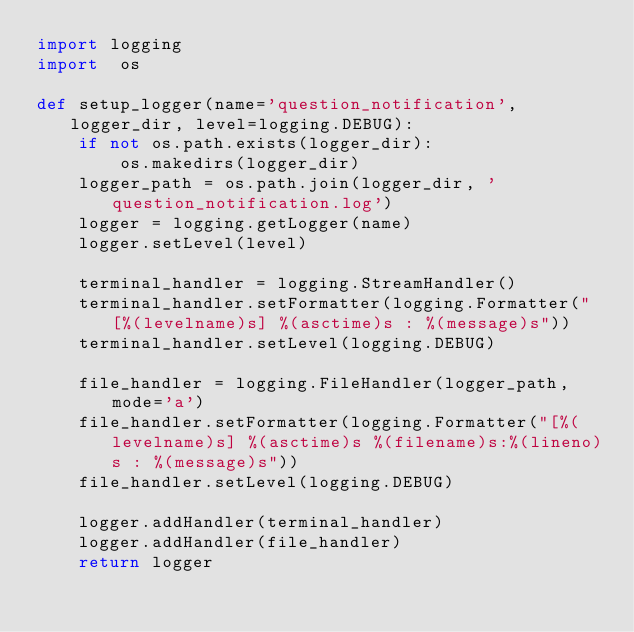<code> <loc_0><loc_0><loc_500><loc_500><_Python_>import logging
import  os

def setup_logger(name='question_notification', logger_dir, level=logging.DEBUG):
    if not os.path.exists(logger_dir):
        os.makedirs(logger_dir)
    logger_path = os.path.join(logger_dir, 'question_notification.log')
    logger = logging.getLogger(name)
    logger.setLevel(level)

    terminal_handler = logging.StreamHandler()
    terminal_handler.setFormatter(logging.Formatter("[%(levelname)s] %(asctime)s : %(message)s"))
    terminal_handler.setLevel(logging.DEBUG)

    file_handler = logging.FileHandler(logger_path, mode='a')
    file_handler.setFormatter(logging.Formatter("[%(levelname)s] %(asctime)s %(filename)s:%(lineno)s : %(message)s"))
    file_handler.setLevel(logging.DEBUG)

    logger.addHandler(terminal_handler)
    logger.addHandler(file_handler)
    return logger
</code> 